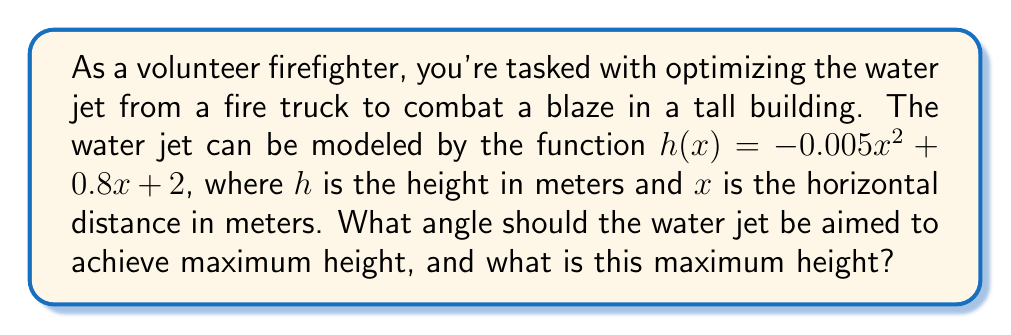Could you help me with this problem? To solve this problem, we'll follow these steps:

1) The function $h(x) = -0.005x^2 + 0.8x + 2$ is a quadratic function. The maximum point of a quadratic function occurs at the vertex of the parabola.

2) For a quadratic function in the form $f(x) = ax^2 + bx + c$, the x-coordinate of the vertex is given by $x = -\frac{b}{2a}$.

3) In our case, $a = -0.005$ and $b = 0.8$. Let's calculate the x-coordinate of the vertex:

   $x = -\frac{0.8}{2(-0.005)} = -\frac{0.8}{-0.01} = 80$ meters

4) To find the maximum height, we plug this x-value back into our original function:

   $h(80) = -0.005(80)^2 + 0.8(80) + 2$
          $= -0.005(6400) + 64 + 2$
          $= -32 + 64 + 2$
          $= 34$ meters

5) To find the angle, we can use the concept that the tangent of the angle at the start of the trajectory (x = 0) is equal to the derivative of the function at that point.

6) The derivative of $h(x) = -0.005x^2 + 0.8x + 2$ is $h'(x) = -0.01x + 0.8$

7) At x = 0, $h'(0) = 0.8$

8) Therefore, $\tan(\theta) = 0.8$

9) $\theta = \arctan(0.8) \approx 38.66°$
Answer: The water jet should be aimed at an angle of approximately 38.66° to achieve a maximum height of 34 meters. 